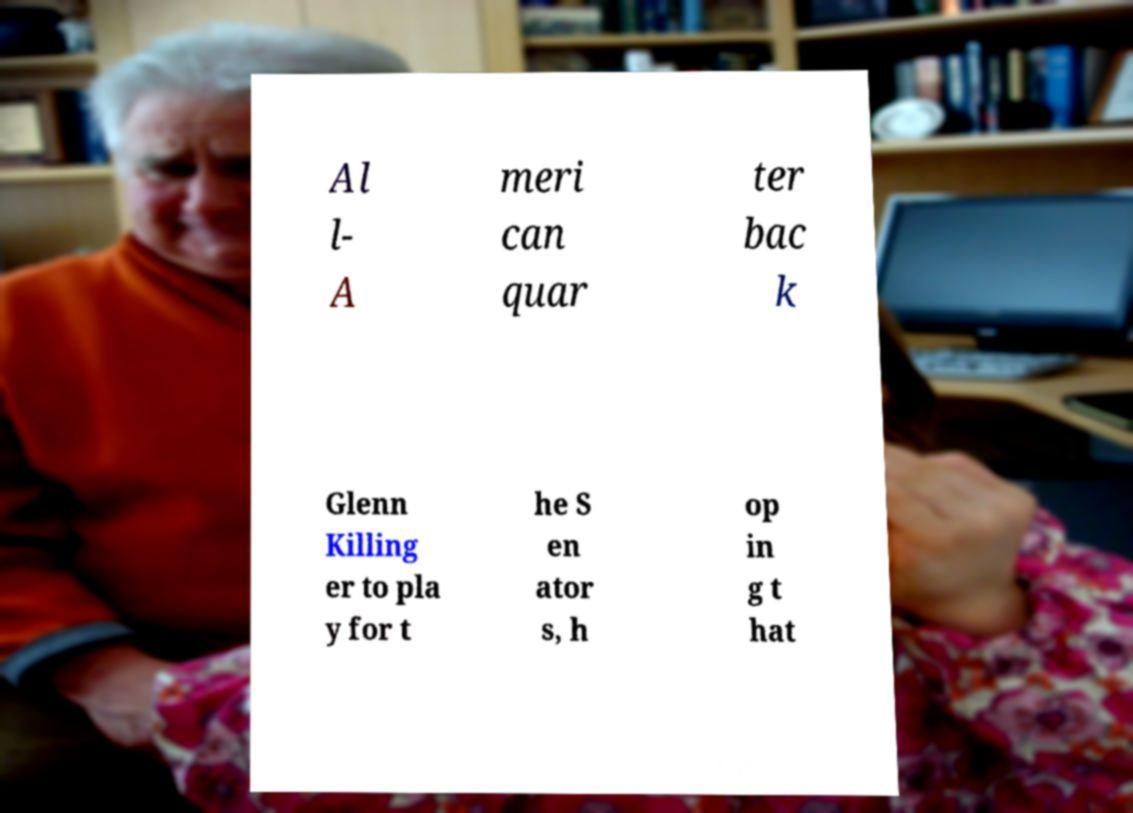Please identify and transcribe the text found in this image. Al l- A meri can quar ter bac k Glenn Killing er to pla y for t he S en ator s, h op in g t hat 